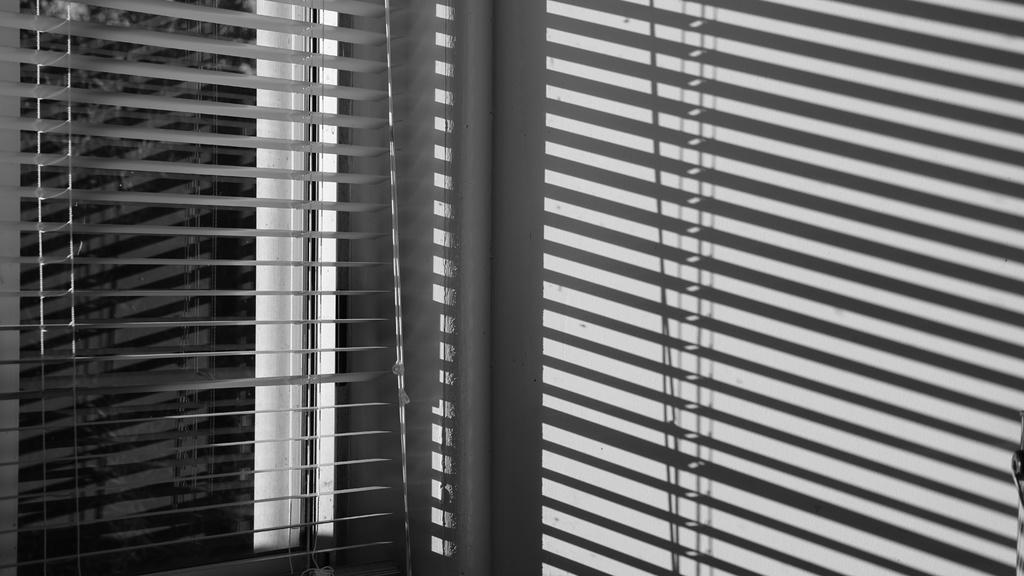What type of window covering is visible in the image? There are window blinds in the image. What color scheme is used in the image? The image is black and white in color. What type of verse is being recited by the lawyer in the image? There is no verse or lawyer present in the image; it only features window blinds in a black and white color scheme. 